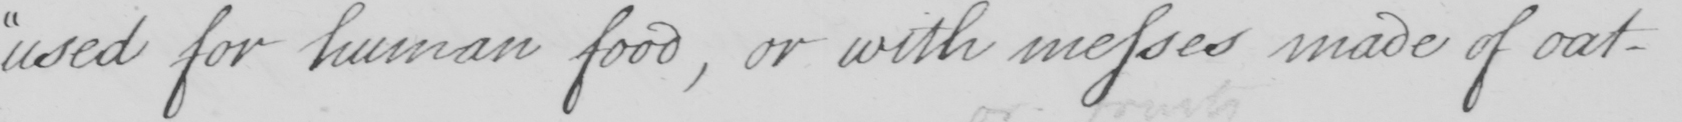Please transcribe the handwritten text in this image. used for human food , or with messes made of oat- 